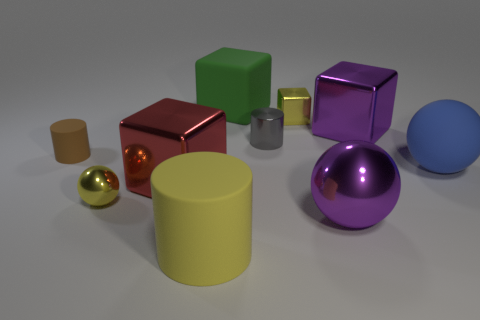If this scene were part of a story, what could it represent? If incorporated into a story, this scene could represent a concept or location where diversity and individuality are valued. It might symbolize a futuristic workshop, a designer's studio, or a showcase of precious artifacts. The various objects might also serve as a metaphor for characters or elements within the narrative. 